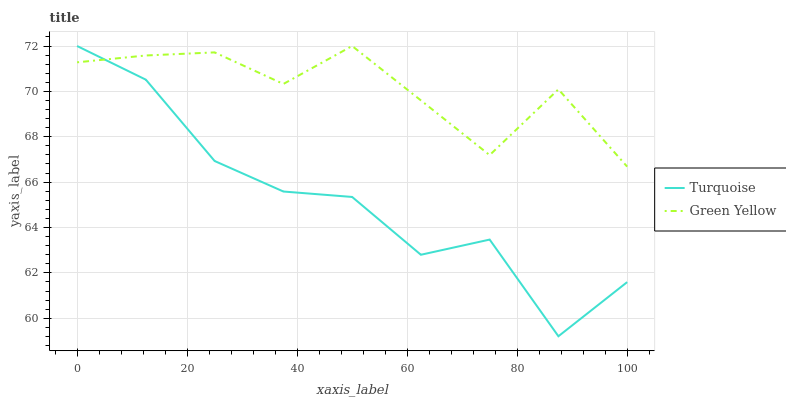Does Turquoise have the minimum area under the curve?
Answer yes or no. Yes. Does Green Yellow have the maximum area under the curve?
Answer yes or no. Yes. Does Green Yellow have the minimum area under the curve?
Answer yes or no. No. Is Green Yellow the smoothest?
Answer yes or no. Yes. Is Turquoise the roughest?
Answer yes or no. Yes. Is Green Yellow the roughest?
Answer yes or no. No. Does Turquoise have the lowest value?
Answer yes or no. Yes. Does Green Yellow have the lowest value?
Answer yes or no. No. Does Green Yellow have the highest value?
Answer yes or no. Yes. Does Green Yellow intersect Turquoise?
Answer yes or no. Yes. Is Green Yellow less than Turquoise?
Answer yes or no. No. Is Green Yellow greater than Turquoise?
Answer yes or no. No. 